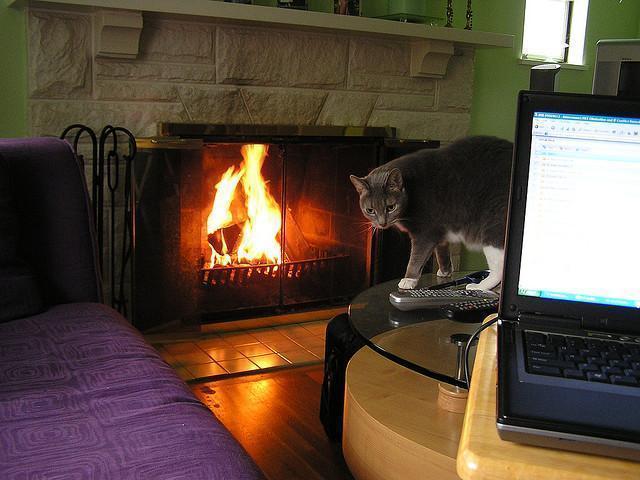What is creeping around on the table?
Select the accurate answer and provide justification: `Answer: choice
Rationale: srationale.`
Options: Mouse, monkey, cat, dog. Answer: cat.
Rationale: There is a gray cat creeping around on the table in front of the fireplace. 